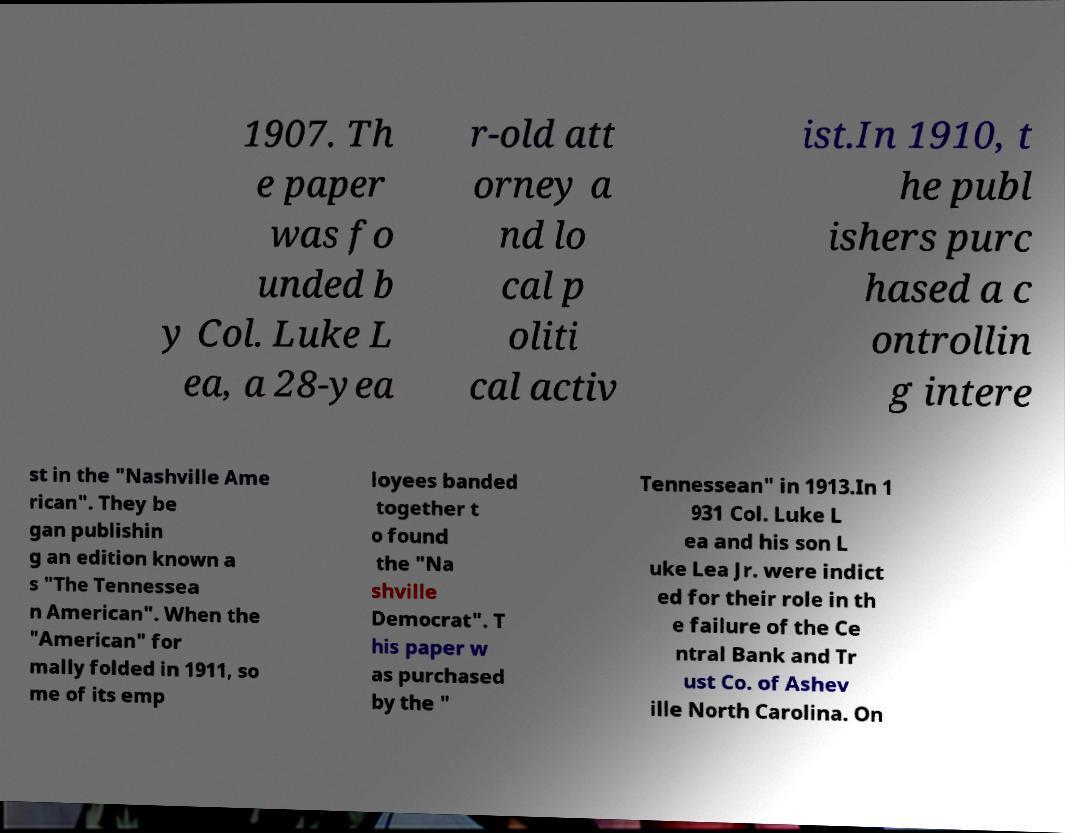Please identify and transcribe the text found in this image. 1907. Th e paper was fo unded b y Col. Luke L ea, a 28-yea r-old att orney a nd lo cal p oliti cal activ ist.In 1910, t he publ ishers purc hased a c ontrollin g intere st in the "Nashville Ame rican". They be gan publishin g an edition known a s "The Tennessea n American". When the "American" for mally folded in 1911, so me of its emp loyees banded together t o found the "Na shville Democrat". T his paper w as purchased by the " Tennessean" in 1913.In 1 931 Col. Luke L ea and his son L uke Lea Jr. were indict ed for their role in th e failure of the Ce ntral Bank and Tr ust Co. of Ashev ille North Carolina. On 